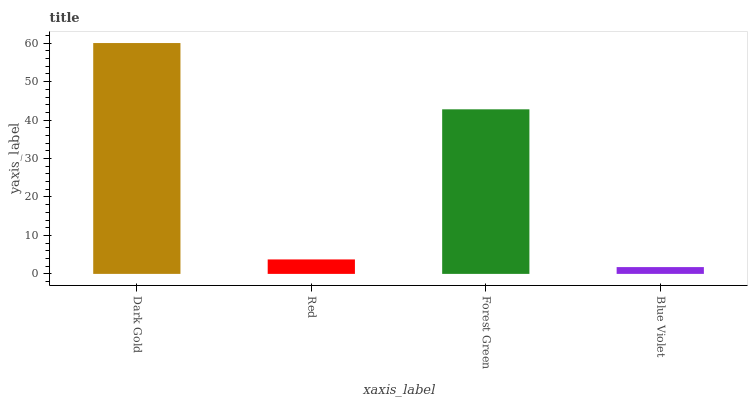Is Red the minimum?
Answer yes or no. No. Is Red the maximum?
Answer yes or no. No. Is Dark Gold greater than Red?
Answer yes or no. Yes. Is Red less than Dark Gold?
Answer yes or no. Yes. Is Red greater than Dark Gold?
Answer yes or no. No. Is Dark Gold less than Red?
Answer yes or no. No. Is Forest Green the high median?
Answer yes or no. Yes. Is Red the low median?
Answer yes or no. Yes. Is Dark Gold the high median?
Answer yes or no. No. Is Forest Green the low median?
Answer yes or no. No. 